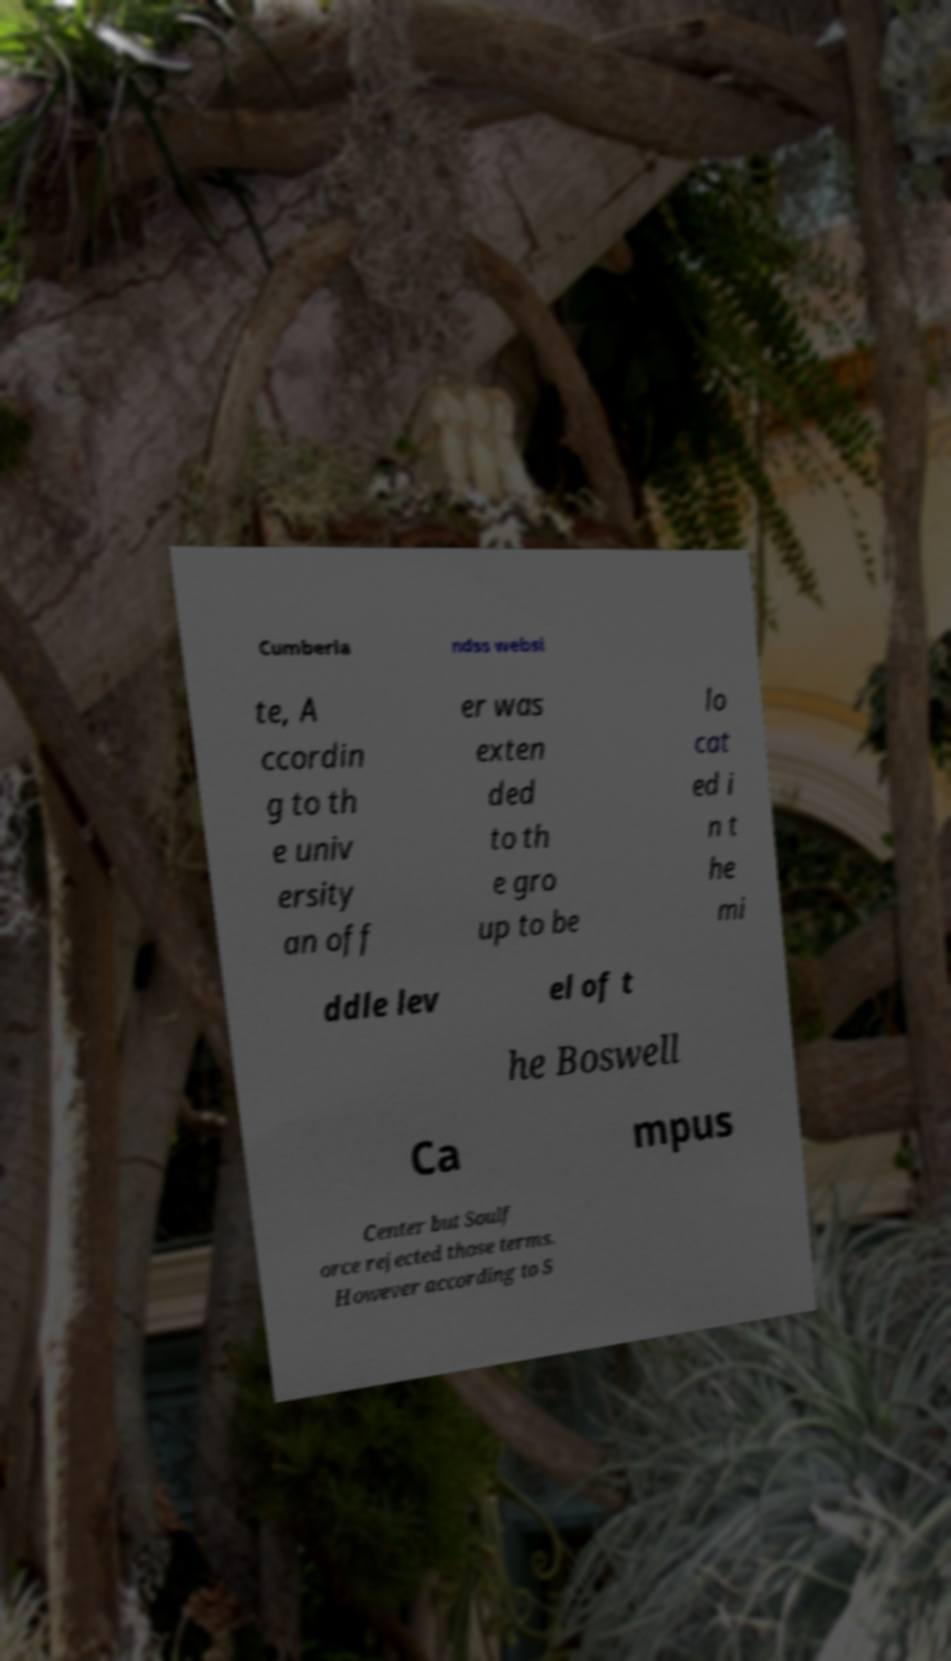There's text embedded in this image that I need extracted. Can you transcribe it verbatim? Cumberla ndss websi te, A ccordin g to th e univ ersity an off er was exten ded to th e gro up to be lo cat ed i n t he mi ddle lev el of t he Boswell Ca mpus Center but Soulf orce rejected those terms. However according to S 